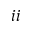Convert formula to latex. <formula><loc_0><loc_0><loc_500><loc_500>i i</formula> 